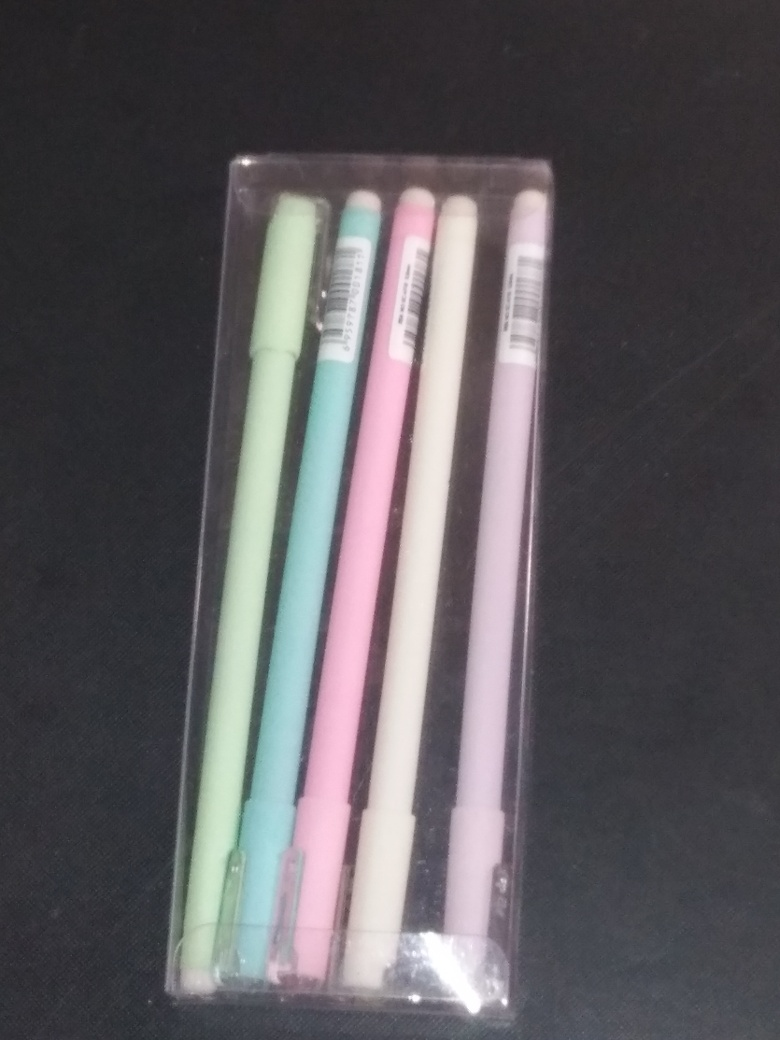Can you tell me more about what's in the image? Certainly! The image shows a set of pastel-colored pens neatly arranged in a transparent plastic case. They are likely to be gel or ballpoint pens, often used for writing or illustration purposes. Each pen has a different color, which could be indicative of their ink color and might be used for organizing notes or artistic projects. 